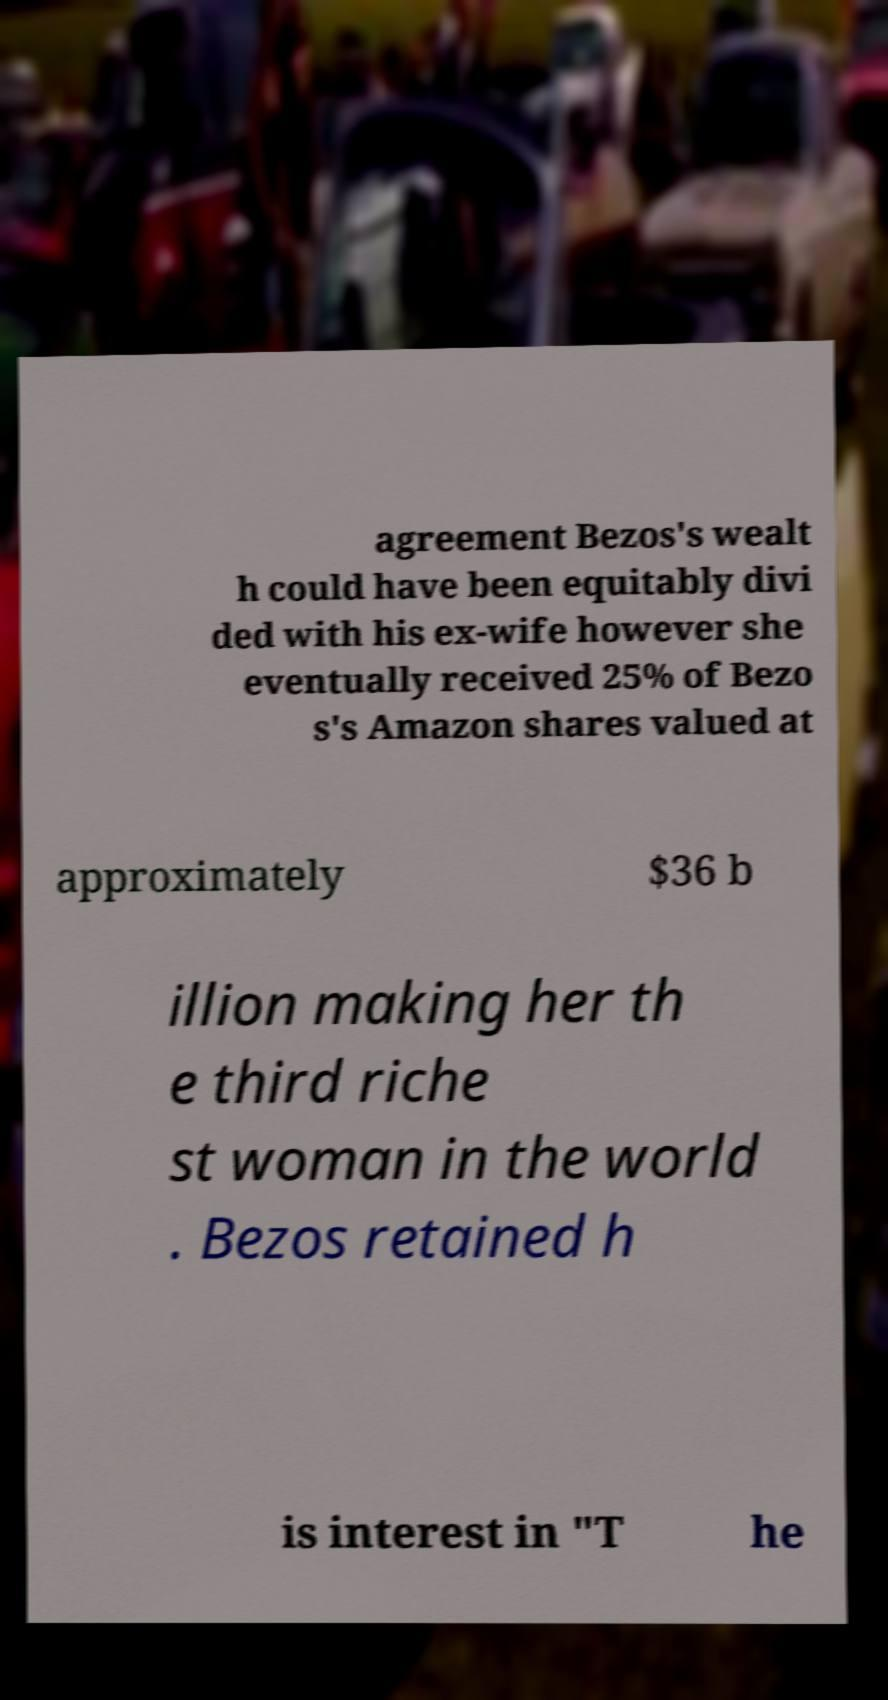Please read and relay the text visible in this image. What does it say? agreement Bezos's wealt h could have been equitably divi ded with his ex-wife however she eventually received 25% of Bezo s's Amazon shares valued at approximately $36 b illion making her th e third riche st woman in the world . Bezos retained h is interest in "T he 